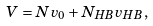Convert formula to latex. <formula><loc_0><loc_0><loc_500><loc_500>V = N v _ { 0 } + N _ { H B } v _ { H B } ,</formula> 